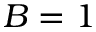<formula> <loc_0><loc_0><loc_500><loc_500>B = 1</formula> 